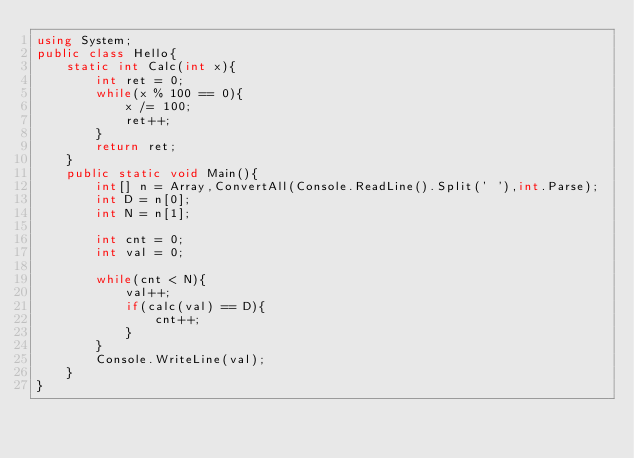<code> <loc_0><loc_0><loc_500><loc_500><_C#_>using System;
public class Hello{
    static int Calc(int x){
        int ret = 0;
        while(x % 100 == 0){
            x /= 100;
            ret++;
        }
        return ret;
    }
    public static void Main(){
        int[] n = Array,ConvertAll(Console.ReadLine().Split(' '),int.Parse);
        int D = n[0];
        int N = n[1];
        
        int cnt = 0;
        int val = 0;
        
        while(cnt < N){
            val++;
            if(calc(val) == D){
                cnt++;
            }
        }
        Console.WriteLine(val);
    }
}
</code> 